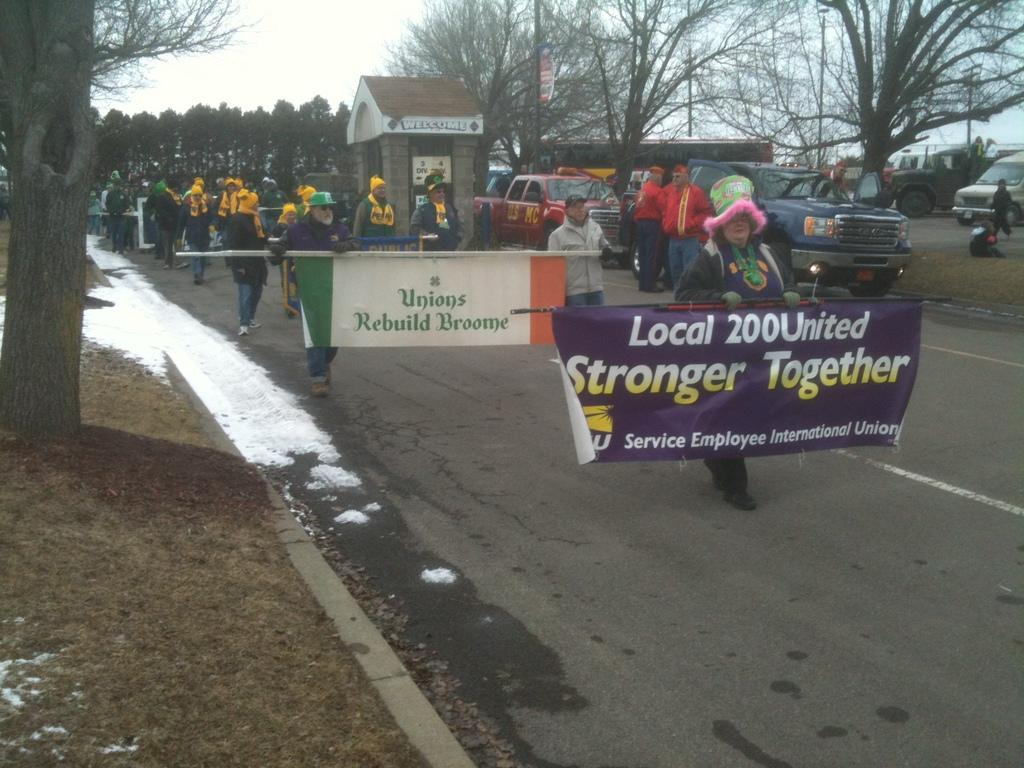<image>
Describe the image concisely. A group of people march down the road, one holding a sign that reads "Stronger Together" 